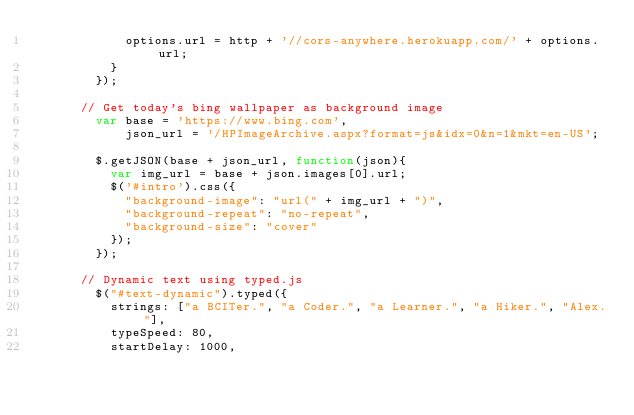<code> <loc_0><loc_0><loc_500><loc_500><_JavaScript_>						options.url = http + '//cors-anywhere.herokuapp.com/' + options.url;
					}
				});

			// Get today's bing wallpaper as background image
				var base = 'https://www.bing.com',
				    json_url = '/HPImageArchive.aspx?format=js&idx=0&n=1&mkt=en-US';
				
				$.getJSON(base + json_url, function(json){
					var img_url = base + json.images[0].url;
					$('#intro').css({
						"background-image": "url(" + img_url + ")",
						"background-repeat": "no-repeat",
						"background-size": "cover"
					});
				});

			// Dynamic text using typed.js
				$("#text-dynamic").typed({
					strings: ["a BCITer.", "a Coder.", "a Learner.", "a Hiker.", "Alex."],
					typeSpeed: 80,
					startDelay: 1000,</code> 